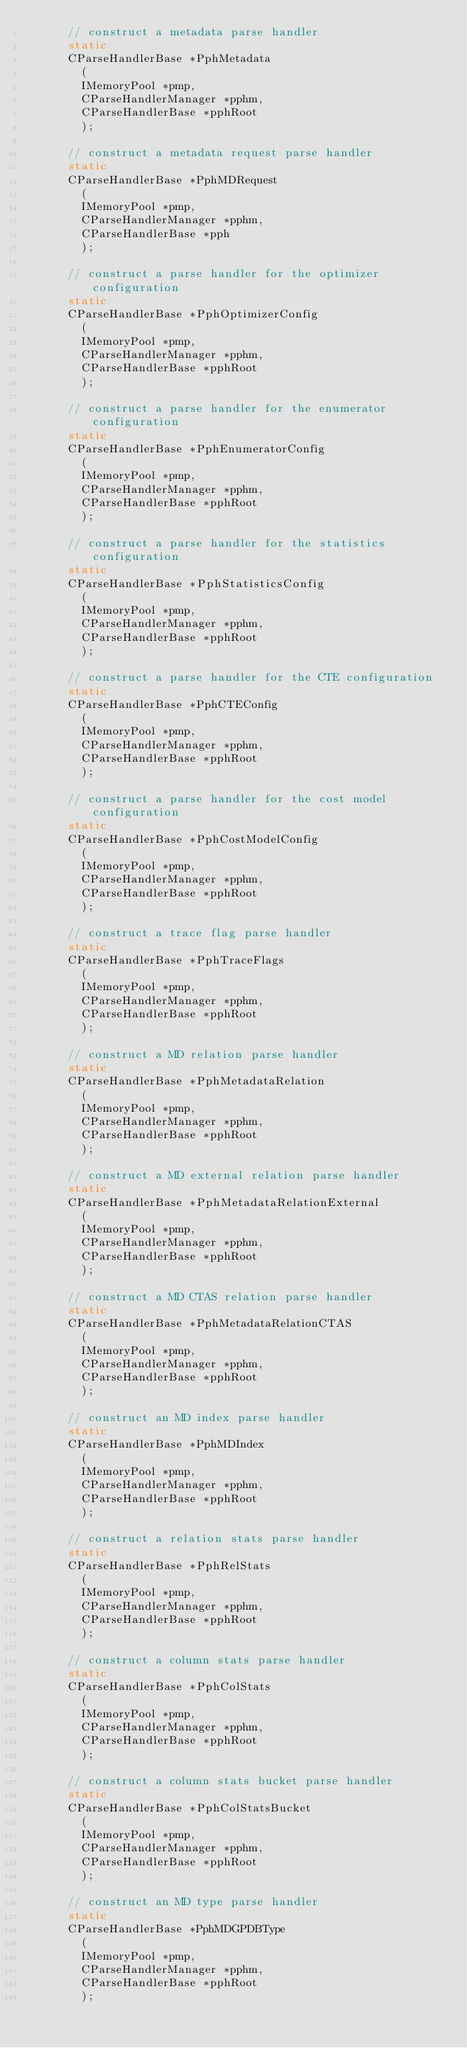Convert code to text. <code><loc_0><loc_0><loc_500><loc_500><_C_>			// construct a metadata parse handler
			static
			CParseHandlerBase *PphMetadata
				(
				IMemoryPool *pmp,
				CParseHandlerManager *pphm,
				CParseHandlerBase *pphRoot
				);
			
			// construct a metadata request parse handler
			static
			CParseHandlerBase *PphMDRequest
				(
				IMemoryPool *pmp,
				CParseHandlerManager *pphm,
				CParseHandlerBase *pph
				);
			
			// construct a parse handler for the optimizer configuration
			static 
			CParseHandlerBase *PphOptimizerConfig
				(
				IMemoryPool *pmp,
				CParseHandlerManager *pphm,
				CParseHandlerBase *pphRoot
				);
			
			// construct a parse handler for the enumerator configuration
			static
			CParseHandlerBase *PphEnumeratorConfig
				(
				IMemoryPool *pmp,
				CParseHandlerManager *pphm,
				CParseHandlerBase *pphRoot
				);

			// construct a parse handler for the statistics configuration
			static
			CParseHandlerBase *PphStatisticsConfig
				(
				IMemoryPool *pmp,
				CParseHandlerManager *pphm,
				CParseHandlerBase *pphRoot
				);

			// construct a parse handler for the CTE configuration
			static
			CParseHandlerBase *PphCTEConfig
				(
				IMemoryPool *pmp,
				CParseHandlerManager *pphm,
				CParseHandlerBase *pphRoot
				);

			// construct a parse handler for the cost model configuration
			static
			CParseHandlerBase *PphCostModelConfig
				(
				IMemoryPool *pmp,
				CParseHandlerManager *pphm,
				CParseHandlerBase *pphRoot
				);
			
			// construct a trace flag parse handler
			static 
			CParseHandlerBase *PphTraceFlags
				(
				IMemoryPool *pmp,
				CParseHandlerManager *pphm,
				CParseHandlerBase *pphRoot
				);
			
			// construct a MD relation parse handler
			static 
			CParseHandlerBase *PphMetadataRelation
				(
				IMemoryPool *pmp,
				CParseHandlerManager *pphm,
				CParseHandlerBase *pphRoot
				);
			
			// construct a MD external relation parse handler
			static
			CParseHandlerBase *PphMetadataRelationExternal
				(
				IMemoryPool *pmp,
				CParseHandlerManager *pphm,
				CParseHandlerBase *pphRoot
				);
			
			// construct a MD CTAS relation parse handler
			static
			CParseHandlerBase *PphMetadataRelationCTAS
				(
				IMemoryPool *pmp,
				CParseHandlerManager *pphm,
				CParseHandlerBase *pphRoot
				);

			// construct an MD index parse handler
			static 
			CParseHandlerBase *PphMDIndex
				(
				IMemoryPool *pmp,
				CParseHandlerManager *pphm,
				CParseHandlerBase *pphRoot
				);
			
			// construct a relation stats parse handler
			static 
			CParseHandlerBase *PphRelStats
				(
				IMemoryPool *pmp,
				CParseHandlerManager *pphm,
				CParseHandlerBase *pphRoot
				);
			
			// construct a column stats parse handler
			static 
			CParseHandlerBase *PphColStats
				(
				IMemoryPool *pmp,
				CParseHandlerManager *pphm,
				CParseHandlerBase *pphRoot
				);
			
			// construct a column stats bucket parse handler
			static 
			CParseHandlerBase *PphColStatsBucket
				(
				IMemoryPool *pmp,
				CParseHandlerManager *pphm,
				CParseHandlerBase *pphRoot
				);

			// construct an MD type parse handler
			static
			CParseHandlerBase *PphMDGPDBType
				(
				IMemoryPool *pmp,
				CParseHandlerManager *pphm,
				CParseHandlerBase *pphRoot
				);</code> 